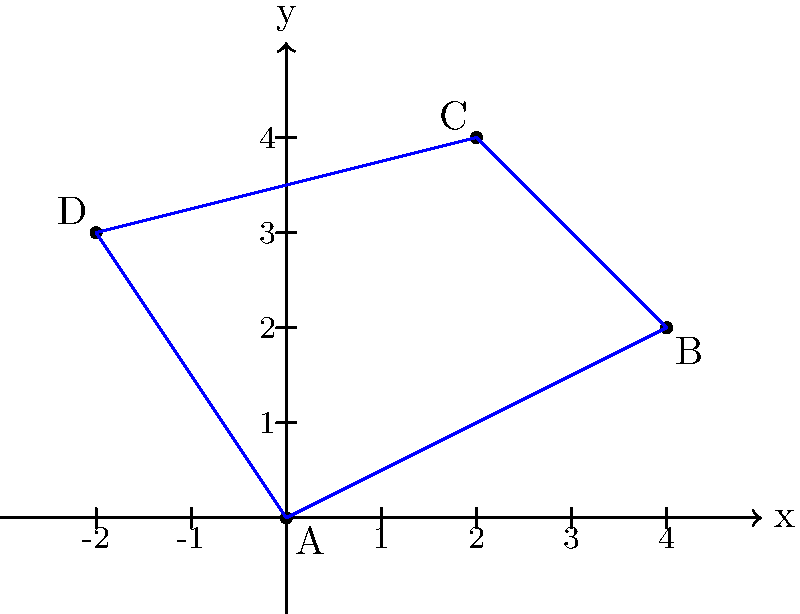During a football play, you want to shift your players' positions on the field. The current positions of four players (A, B, C, and D) are shown on the coordinate grid above. If you translate all players 3 units to the right and 1 unit down, what will be the new coordinates of player C? To solve this problem, we need to follow these steps:

1. Identify the original coordinates of player C:
   Player C is initially at point $(2,4)$

2. Apply the translation:
   - Moving 3 units to the right means adding 3 to the x-coordinate
   - Moving 1 unit down means subtracting 1 from the y-coordinate

3. Calculate the new coordinates:
   - New x-coordinate: $2 + 3 = 5$
   - New y-coordinate: $4 - 1 = 3$

4. Combine the new coordinates:
   The new position of player C after the translation is $(5,3)$

This translation can be represented mathematically as:
$T_{(3,-1)}(x,y) = (x+3, y-1)$

Applying this to player C's original coordinates:
$T_{(3,-1)}(2,4) = (2+3, 4-1) = (5,3)$
Answer: $(5,3)$ 